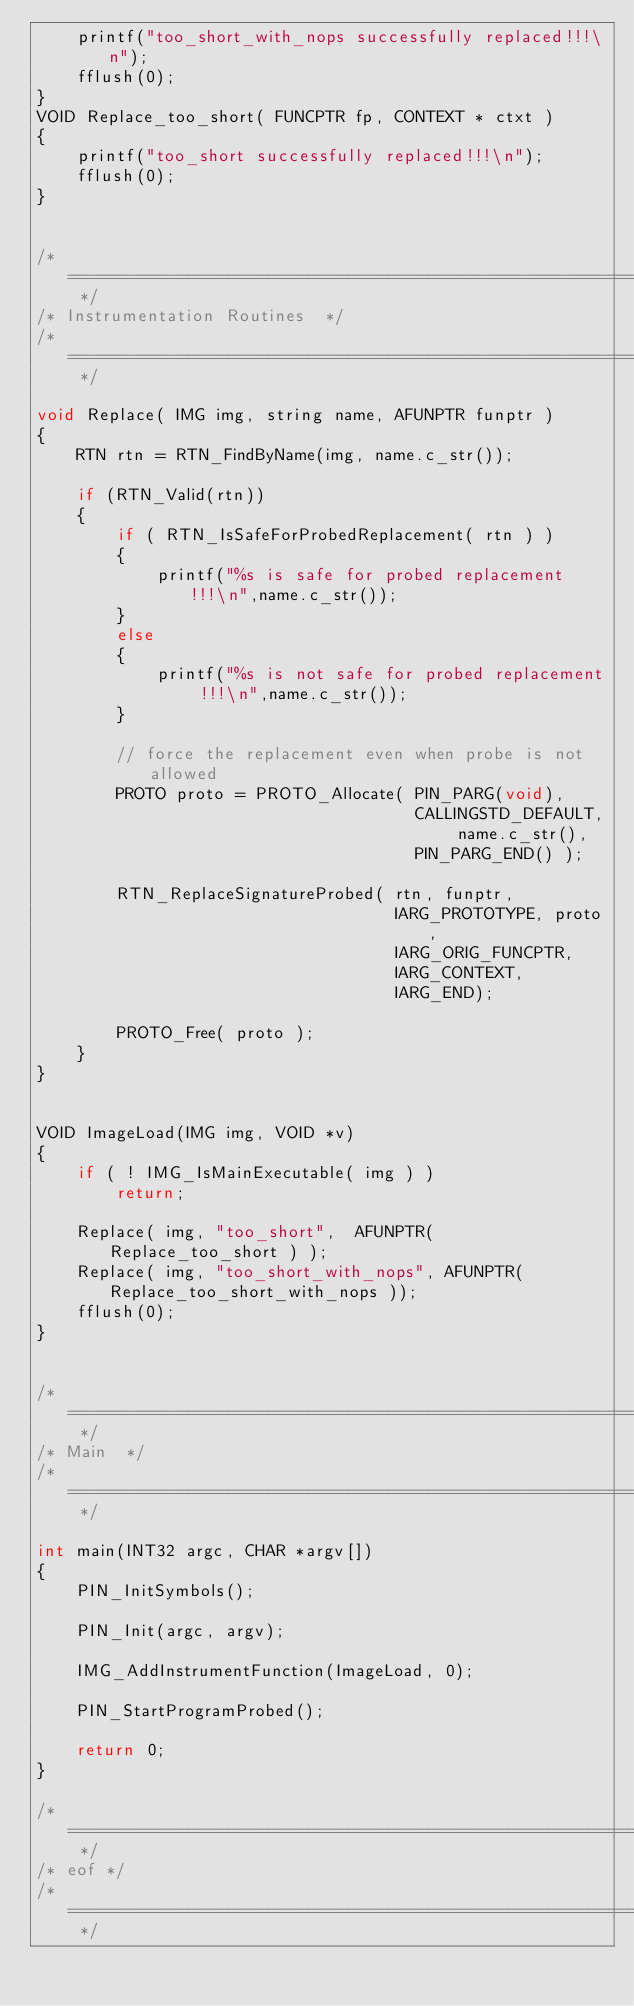Convert code to text. <code><loc_0><loc_0><loc_500><loc_500><_C++_>    printf("too_short_with_nops successfully replaced!!!\n");
    fflush(0);
}
VOID Replace_too_short( FUNCPTR fp, CONTEXT * ctxt )
{
    printf("too_short successfully replaced!!!\n");
    fflush(0);
}


/* ===================================================================== */
/* Instrumentation Routines  */
/* ===================================================================== */

void Replace( IMG img, string name, AFUNPTR funptr )
{
    RTN rtn = RTN_FindByName(img, name.c_str());

    if (RTN_Valid(rtn))
    {
        if ( RTN_IsSafeForProbedReplacement( rtn ) )
        {
            printf("%s is safe for probed replacement !!!\n",name.c_str());
        }
        else
        {
            printf("%s is not safe for probed replacement !!!\n",name.c_str());
        }
        
        // force the replacement even when probe is not allowed
        PROTO proto = PROTO_Allocate( PIN_PARG(void),
                                      CALLINGSTD_DEFAULT, name.c_str(),
                                      PIN_PARG_END() );
        
        RTN_ReplaceSignatureProbed( rtn, funptr,
                                    IARG_PROTOTYPE, proto,
                                    IARG_ORIG_FUNCPTR,
                                    IARG_CONTEXT,
                                    IARG_END);
        
        PROTO_Free( proto );
    }
}


VOID ImageLoad(IMG img, VOID *v)
{
    if ( ! IMG_IsMainExecutable( img ) )
        return;

    Replace( img, "too_short",  AFUNPTR( Replace_too_short ) );
    Replace( img, "too_short_with_nops", AFUNPTR( Replace_too_short_with_nops ));
    fflush(0);
}


/* ===================================================================== */
/* Main  */
/* ===================================================================== */

int main(INT32 argc, CHAR *argv[])
{
    PIN_InitSymbols();

    PIN_Init(argc, argv);

    IMG_AddInstrumentFunction(ImageLoad, 0);
    
    PIN_StartProgramProbed();

    return 0;
}

/* ===================================================================== */
/* eof */
/* ===================================================================== */
    
</code> 